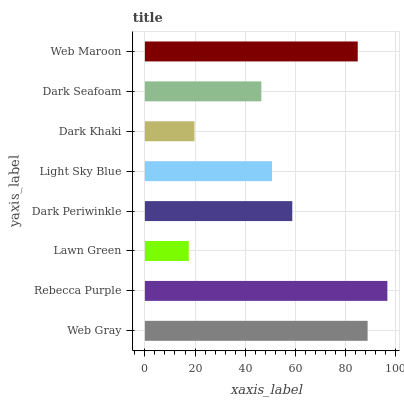Is Lawn Green the minimum?
Answer yes or no. Yes. Is Rebecca Purple the maximum?
Answer yes or no. Yes. Is Rebecca Purple the minimum?
Answer yes or no. No. Is Lawn Green the maximum?
Answer yes or no. No. Is Rebecca Purple greater than Lawn Green?
Answer yes or no. Yes. Is Lawn Green less than Rebecca Purple?
Answer yes or no. Yes. Is Lawn Green greater than Rebecca Purple?
Answer yes or no. No. Is Rebecca Purple less than Lawn Green?
Answer yes or no. No. Is Dark Periwinkle the high median?
Answer yes or no. Yes. Is Light Sky Blue the low median?
Answer yes or no. Yes. Is Lawn Green the high median?
Answer yes or no. No. Is Rebecca Purple the low median?
Answer yes or no. No. 